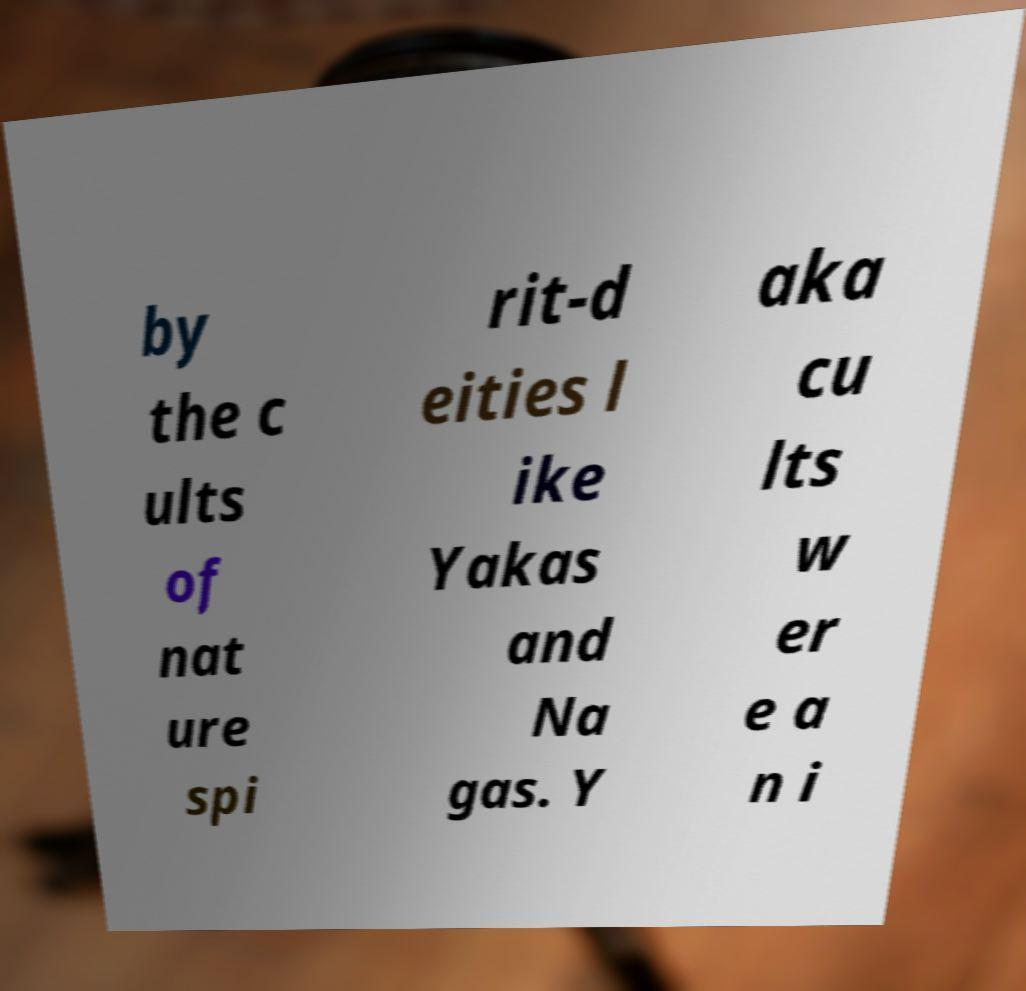Can you accurately transcribe the text from the provided image for me? by the c ults of nat ure spi rit-d eities l ike Yakas and Na gas. Y aka cu lts w er e a n i 